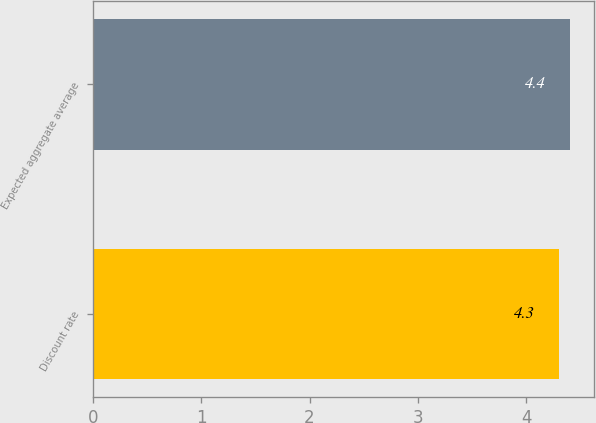<chart> <loc_0><loc_0><loc_500><loc_500><bar_chart><fcel>Discount rate<fcel>Expected aggregate average<nl><fcel>4.3<fcel>4.4<nl></chart> 